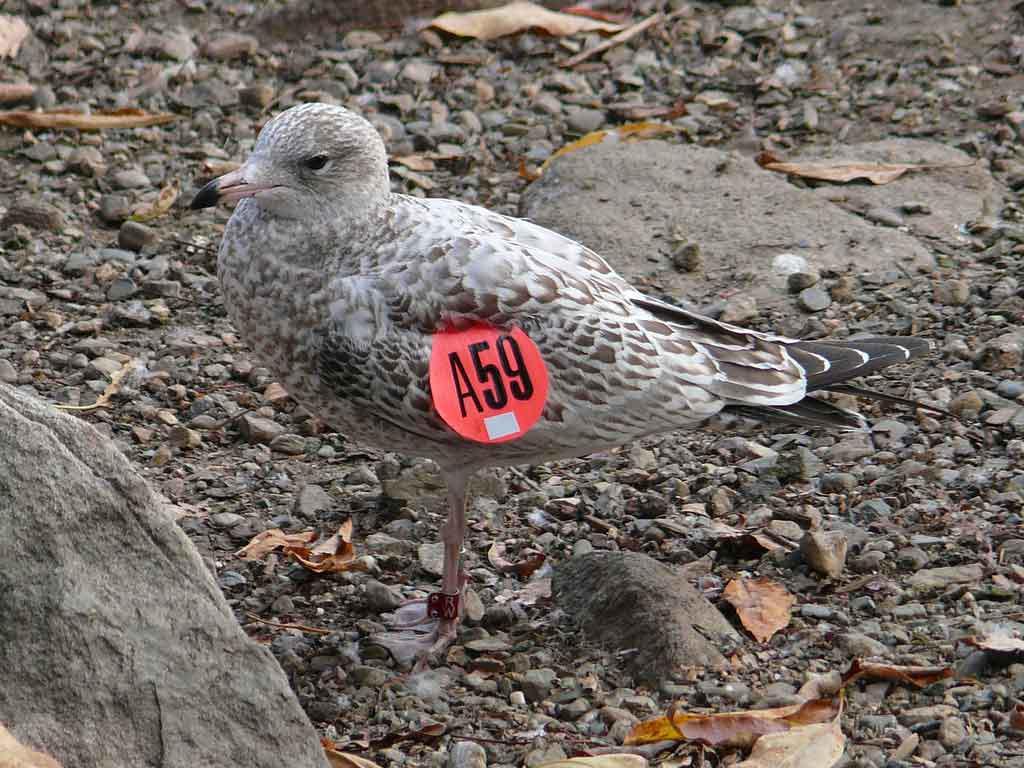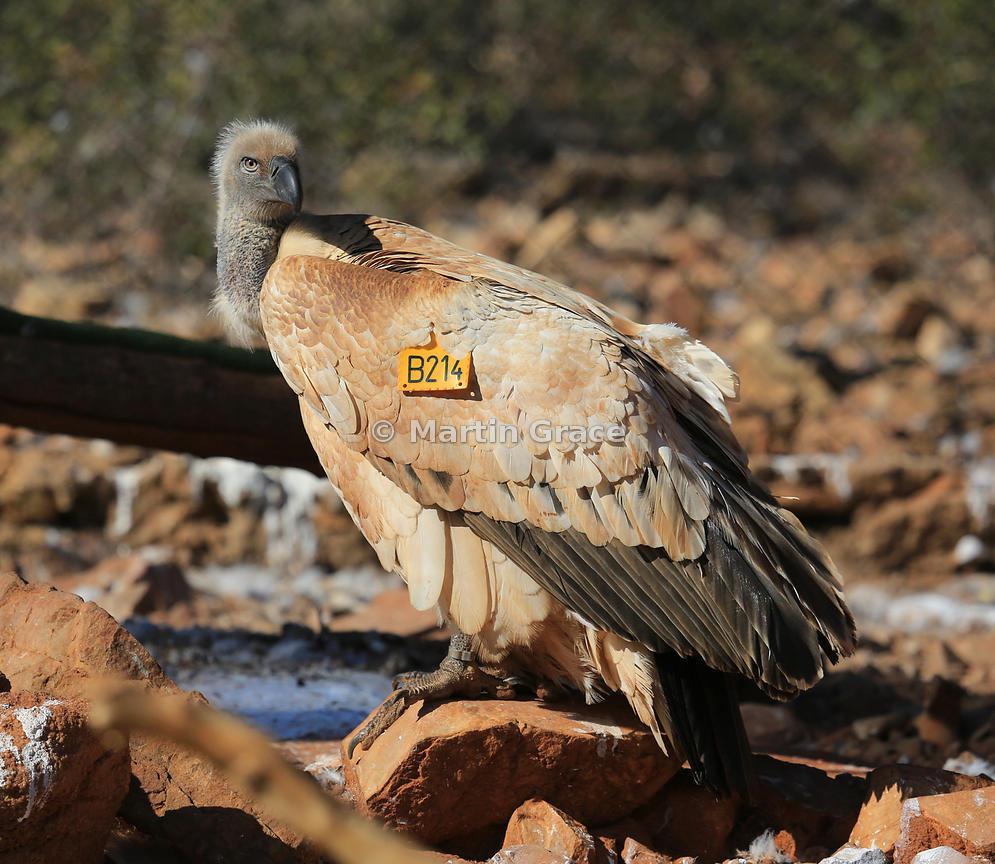The first image is the image on the left, the second image is the image on the right. Considering the images on both sides, is "In one image, you can see a line of hooved-type animals in the background behind the vultures." valid? Answer yes or no. No. The first image is the image on the left, the second image is the image on the right. Examine the images to the left and right. Is the description "There are two flying birds in the image on the left." accurate? Answer yes or no. No. 